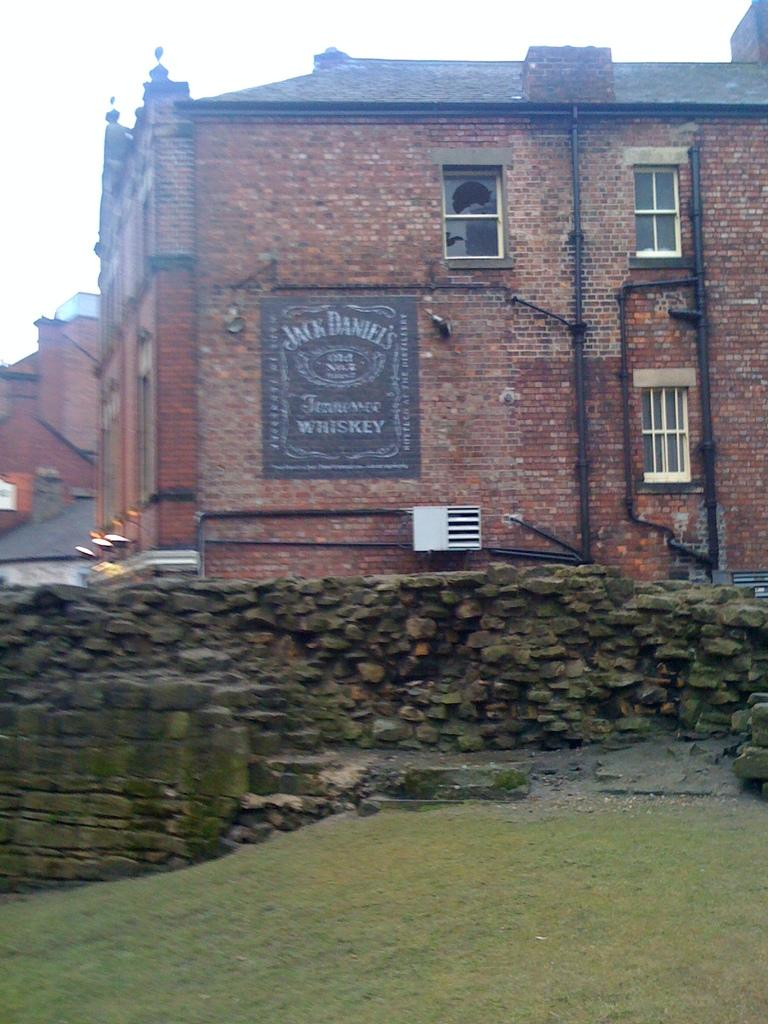What type of surface is present at the bottom of the image? There is grass on the surface at the bottom of the image. What type of structure can be seen in the image? There is a rock wall in the image. What can be seen in the distance in the image? There are buildings and lights visible in the background of the image. What is visible in the sky in the image? The sky is visible in the background of the image. Can you see a hydrant near the grass in the image? There is no hydrant visible in the image; only grass, a rock wall, and the background elements are present. 